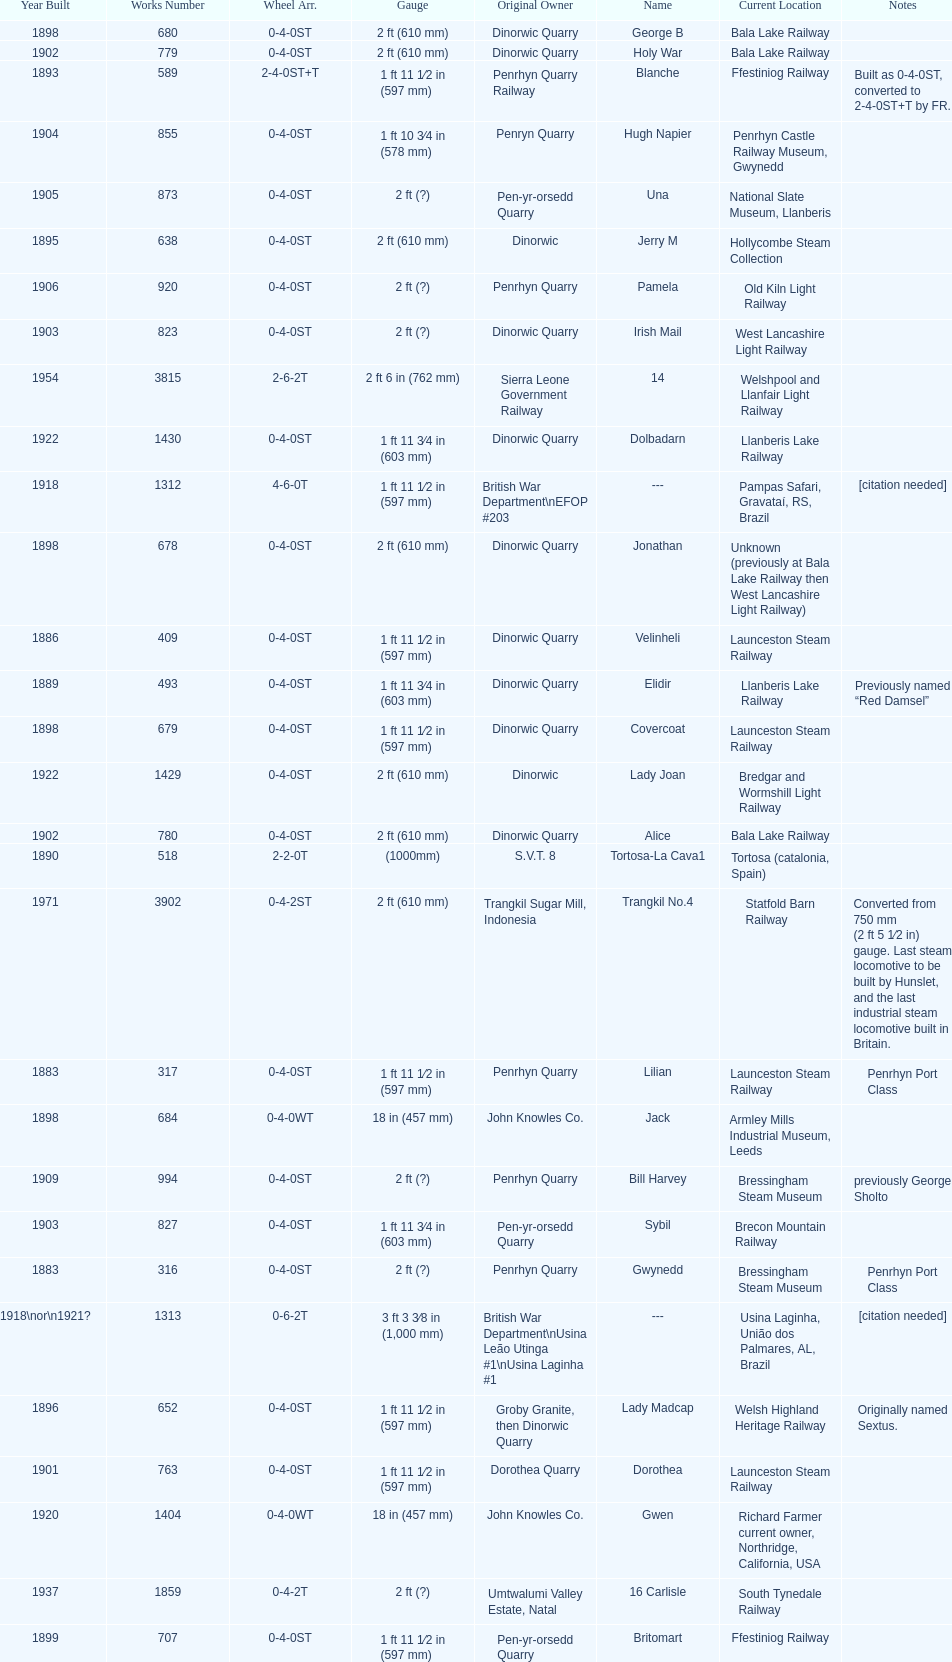How many steam locomotives are currently located at the bala lake railway? 364. 